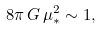<formula> <loc_0><loc_0><loc_500><loc_500>8 \pi \, G \, \mu _ { * } ^ { 2 } \sim 1 ,</formula> 